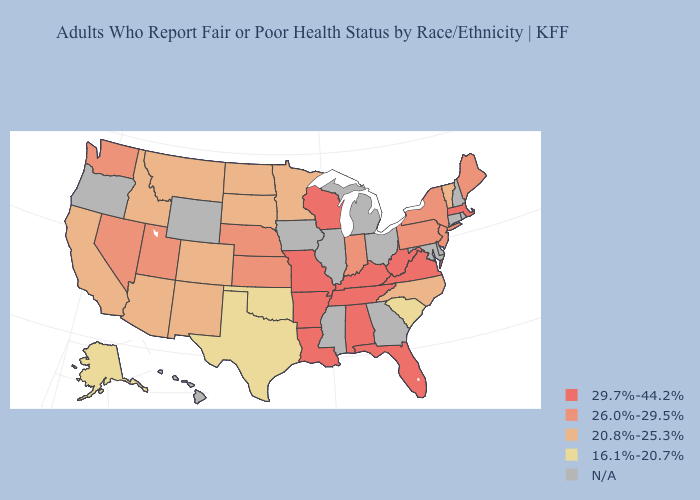What is the highest value in states that border Florida?
Answer briefly. 29.7%-44.2%. What is the value of Rhode Island?
Be succinct. N/A. Name the states that have a value in the range 26.0%-29.5%?
Short answer required. Indiana, Kansas, Maine, Nebraska, Nevada, New Jersey, New York, Pennsylvania, Utah, Washington. What is the value of Michigan?
Give a very brief answer. N/A. What is the value of Iowa?
Quick response, please. N/A. How many symbols are there in the legend?
Concise answer only. 5. Is the legend a continuous bar?
Answer briefly. No. What is the lowest value in states that border Texas?
Short answer required. 16.1%-20.7%. Name the states that have a value in the range 26.0%-29.5%?
Write a very short answer. Indiana, Kansas, Maine, Nebraska, Nevada, New Jersey, New York, Pennsylvania, Utah, Washington. What is the value of Florida?
Concise answer only. 29.7%-44.2%. Name the states that have a value in the range 29.7%-44.2%?
Keep it brief. Alabama, Arkansas, Florida, Kentucky, Louisiana, Massachusetts, Missouri, Tennessee, Virginia, West Virginia, Wisconsin. Does Massachusetts have the highest value in the Northeast?
Write a very short answer. Yes. What is the value of Wisconsin?
Write a very short answer. 29.7%-44.2%. What is the value of Minnesota?
Concise answer only. 20.8%-25.3%. 